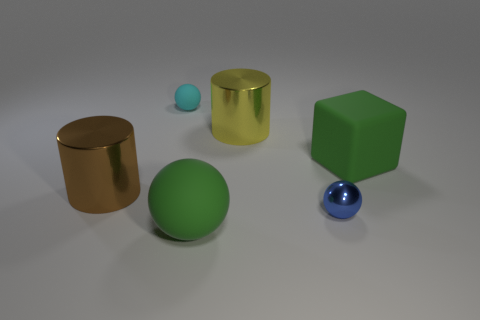Subtract all blue balls. How many balls are left? 2 Subtract all blue balls. How many balls are left? 2 Add 1 green cylinders. How many objects exist? 7 Subtract all gray cylinders. Subtract all purple cubes. How many cylinders are left? 2 Subtract 0 yellow balls. How many objects are left? 6 Subtract all blocks. How many objects are left? 5 Subtract all metal spheres. Subtract all large brown metallic cylinders. How many objects are left? 4 Add 2 small cyan rubber things. How many small cyan rubber things are left? 3 Add 4 brown metal things. How many brown metal things exist? 5 